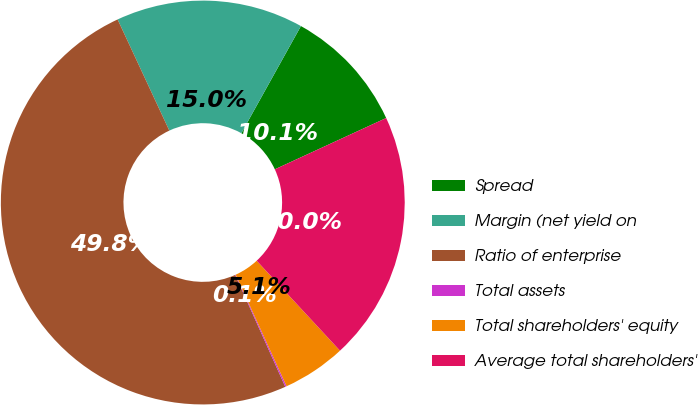Convert chart to OTSL. <chart><loc_0><loc_0><loc_500><loc_500><pie_chart><fcel>Spread<fcel>Margin (net yield on<fcel>Ratio of enterprise<fcel>Total assets<fcel>Total shareholders' equity<fcel>Average total shareholders'<nl><fcel>10.05%<fcel>15.01%<fcel>49.77%<fcel>0.11%<fcel>5.08%<fcel>19.98%<nl></chart> 